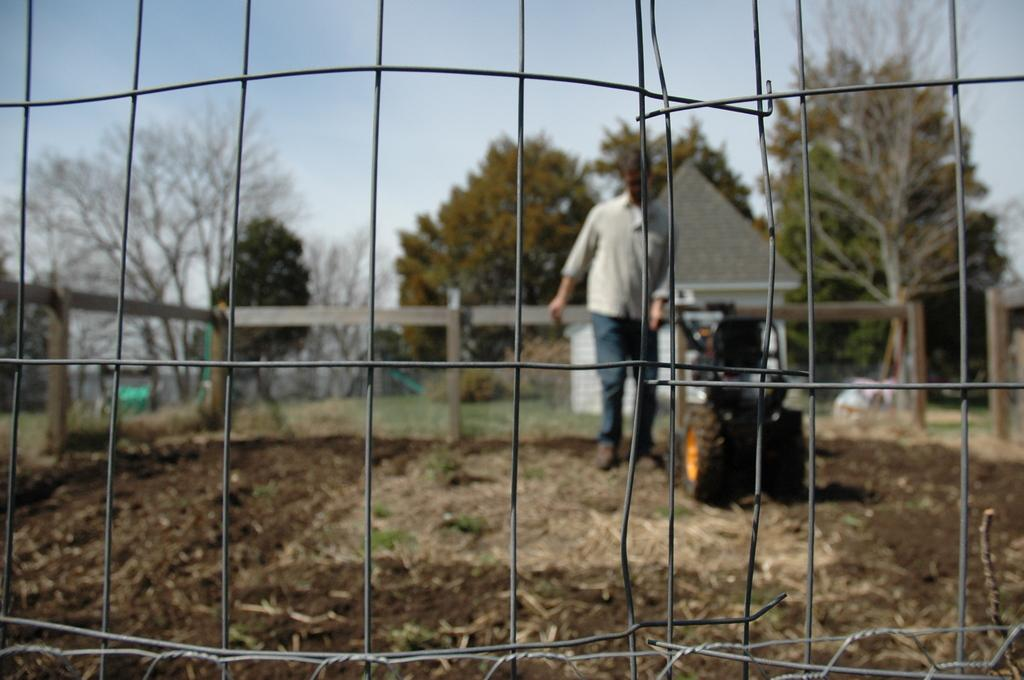What is the main subject of the image? There is a man in the image. What is the man doing in the image? The man is standing and holding a lawn mower. What can be seen in the foreground of the image? There is a mesh in the foreground of the image. What structures are visible in the background of the image? There is a shed, trees, and a fence in the background of the image. What part of the natural environment is visible in the image? The sky is visible in the background of the image. What type of dress is the snail wearing in the image? There is no snail or dress present in the image. 